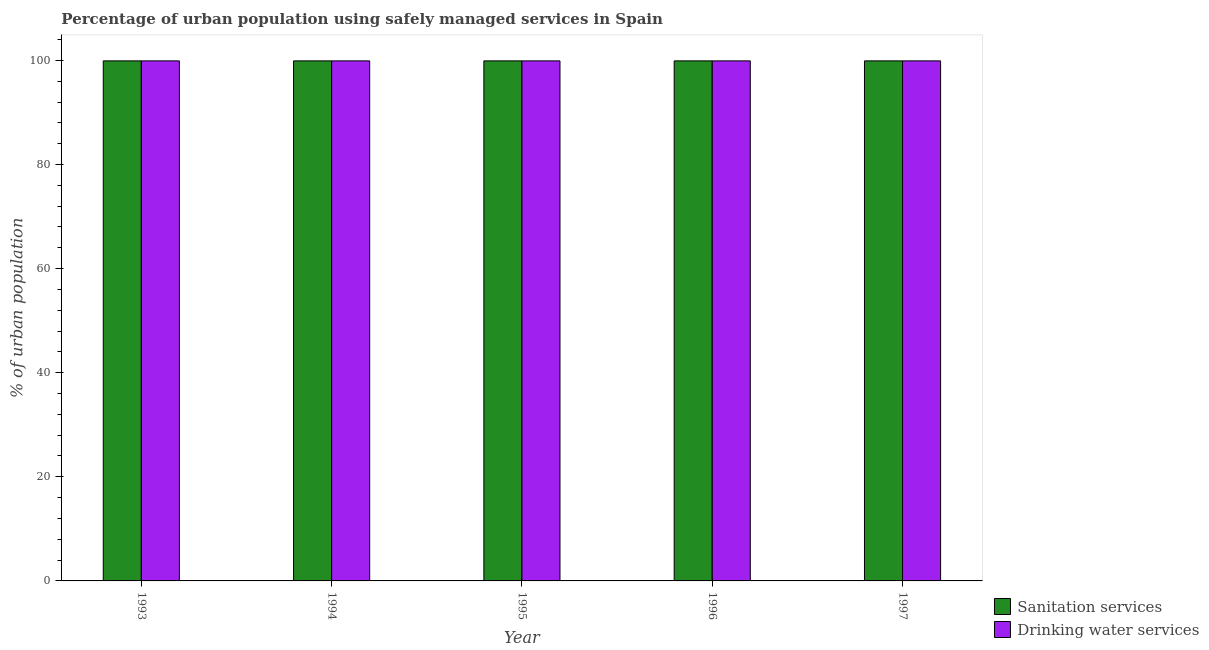How many different coloured bars are there?
Provide a succinct answer. 2. Are the number of bars per tick equal to the number of legend labels?
Your response must be concise. Yes. What is the label of the 5th group of bars from the left?
Give a very brief answer. 1997. What is the percentage of urban population who used sanitation services in 1994?
Offer a terse response. 99.9. Across all years, what is the maximum percentage of urban population who used sanitation services?
Give a very brief answer. 99.9. Across all years, what is the minimum percentage of urban population who used sanitation services?
Provide a succinct answer. 99.9. What is the total percentage of urban population who used drinking water services in the graph?
Provide a short and direct response. 499.5. What is the difference between the percentage of urban population who used drinking water services in 1993 and that in 1994?
Ensure brevity in your answer.  0. What is the average percentage of urban population who used drinking water services per year?
Offer a very short reply. 99.9. Is the percentage of urban population who used drinking water services in 1994 less than that in 1997?
Your answer should be compact. No. What is the difference between the highest and the second highest percentage of urban population who used sanitation services?
Provide a short and direct response. 0. In how many years, is the percentage of urban population who used sanitation services greater than the average percentage of urban population who used sanitation services taken over all years?
Give a very brief answer. 0. What does the 2nd bar from the left in 1995 represents?
Provide a short and direct response. Drinking water services. What does the 1st bar from the right in 1993 represents?
Offer a terse response. Drinking water services. How many bars are there?
Ensure brevity in your answer.  10. How many years are there in the graph?
Make the answer very short. 5. What is the difference between two consecutive major ticks on the Y-axis?
Keep it short and to the point. 20. Does the graph contain any zero values?
Your answer should be very brief. No. Does the graph contain grids?
Ensure brevity in your answer.  No. Where does the legend appear in the graph?
Offer a terse response. Bottom right. How many legend labels are there?
Your answer should be very brief. 2. What is the title of the graph?
Ensure brevity in your answer.  Percentage of urban population using safely managed services in Spain. What is the label or title of the X-axis?
Your response must be concise. Year. What is the label or title of the Y-axis?
Your response must be concise. % of urban population. What is the % of urban population of Sanitation services in 1993?
Your answer should be very brief. 99.9. What is the % of urban population of Drinking water services in 1993?
Offer a very short reply. 99.9. What is the % of urban population of Sanitation services in 1994?
Your response must be concise. 99.9. What is the % of urban population in Drinking water services in 1994?
Keep it short and to the point. 99.9. What is the % of urban population in Sanitation services in 1995?
Make the answer very short. 99.9. What is the % of urban population in Drinking water services in 1995?
Provide a short and direct response. 99.9. What is the % of urban population in Sanitation services in 1996?
Make the answer very short. 99.9. What is the % of urban population of Drinking water services in 1996?
Provide a short and direct response. 99.9. What is the % of urban population of Sanitation services in 1997?
Your answer should be compact. 99.9. What is the % of urban population in Drinking water services in 1997?
Keep it short and to the point. 99.9. Across all years, what is the maximum % of urban population in Sanitation services?
Make the answer very short. 99.9. Across all years, what is the maximum % of urban population in Drinking water services?
Your response must be concise. 99.9. Across all years, what is the minimum % of urban population in Sanitation services?
Offer a very short reply. 99.9. Across all years, what is the minimum % of urban population of Drinking water services?
Ensure brevity in your answer.  99.9. What is the total % of urban population in Sanitation services in the graph?
Your answer should be compact. 499.5. What is the total % of urban population in Drinking water services in the graph?
Your answer should be compact. 499.5. What is the difference between the % of urban population of Sanitation services in 1993 and that in 1994?
Your response must be concise. 0. What is the difference between the % of urban population in Drinking water services in 1993 and that in 1994?
Ensure brevity in your answer.  0. What is the difference between the % of urban population in Drinking water services in 1993 and that in 1995?
Make the answer very short. 0. What is the difference between the % of urban population in Drinking water services in 1993 and that in 1996?
Provide a short and direct response. 0. What is the difference between the % of urban population of Sanitation services in 1993 and that in 1997?
Offer a very short reply. 0. What is the difference between the % of urban population in Drinking water services in 1993 and that in 1997?
Keep it short and to the point. 0. What is the difference between the % of urban population of Drinking water services in 1994 and that in 1995?
Your answer should be compact. 0. What is the difference between the % of urban population in Sanitation services in 1994 and that in 1996?
Your answer should be very brief. 0. What is the difference between the % of urban population in Drinking water services in 1994 and that in 1996?
Your answer should be very brief. 0. What is the difference between the % of urban population in Sanitation services in 1994 and that in 1997?
Your answer should be compact. 0. What is the difference between the % of urban population of Drinking water services in 1995 and that in 1996?
Provide a short and direct response. 0. What is the difference between the % of urban population in Sanitation services in 1995 and that in 1997?
Provide a succinct answer. 0. What is the difference between the % of urban population in Drinking water services in 1995 and that in 1997?
Keep it short and to the point. 0. What is the difference between the % of urban population in Drinking water services in 1996 and that in 1997?
Make the answer very short. 0. What is the difference between the % of urban population in Sanitation services in 1993 and the % of urban population in Drinking water services in 1994?
Make the answer very short. 0. What is the difference between the % of urban population of Sanitation services in 1993 and the % of urban population of Drinking water services in 1995?
Offer a terse response. 0. What is the difference between the % of urban population of Sanitation services in 1993 and the % of urban population of Drinking water services in 1997?
Offer a very short reply. 0. What is the difference between the % of urban population of Sanitation services in 1994 and the % of urban population of Drinking water services in 1996?
Provide a short and direct response. 0. What is the difference between the % of urban population of Sanitation services in 1994 and the % of urban population of Drinking water services in 1997?
Your response must be concise. 0. What is the difference between the % of urban population of Sanitation services in 1995 and the % of urban population of Drinking water services in 1996?
Give a very brief answer. 0. What is the difference between the % of urban population in Sanitation services in 1996 and the % of urban population in Drinking water services in 1997?
Make the answer very short. 0. What is the average % of urban population in Sanitation services per year?
Make the answer very short. 99.9. What is the average % of urban population in Drinking water services per year?
Your response must be concise. 99.9. In the year 1994, what is the difference between the % of urban population of Sanitation services and % of urban population of Drinking water services?
Provide a short and direct response. 0. In the year 1995, what is the difference between the % of urban population of Sanitation services and % of urban population of Drinking water services?
Your answer should be very brief. 0. In the year 1997, what is the difference between the % of urban population of Sanitation services and % of urban population of Drinking water services?
Make the answer very short. 0. What is the ratio of the % of urban population in Sanitation services in 1993 to that in 1994?
Keep it short and to the point. 1. What is the ratio of the % of urban population of Drinking water services in 1993 to that in 1994?
Your answer should be very brief. 1. What is the ratio of the % of urban population of Drinking water services in 1993 to that in 1995?
Offer a very short reply. 1. What is the ratio of the % of urban population in Sanitation services in 1993 to that in 1996?
Your response must be concise. 1. What is the ratio of the % of urban population of Drinking water services in 1993 to that in 1996?
Provide a short and direct response. 1. What is the ratio of the % of urban population in Sanitation services in 1993 to that in 1997?
Provide a short and direct response. 1. What is the ratio of the % of urban population in Sanitation services in 1994 to that in 1995?
Provide a succinct answer. 1. What is the ratio of the % of urban population of Drinking water services in 1994 to that in 1995?
Provide a succinct answer. 1. What is the ratio of the % of urban population in Sanitation services in 1994 to that in 1996?
Offer a very short reply. 1. What is the ratio of the % of urban population of Drinking water services in 1994 to that in 1996?
Give a very brief answer. 1. What is the ratio of the % of urban population in Drinking water services in 1994 to that in 1997?
Your answer should be compact. 1. What is the ratio of the % of urban population in Sanitation services in 1995 to that in 1996?
Your answer should be compact. 1. What is the ratio of the % of urban population in Sanitation services in 1996 to that in 1997?
Ensure brevity in your answer.  1. What is the difference between the highest and the second highest % of urban population of Drinking water services?
Provide a short and direct response. 0. 